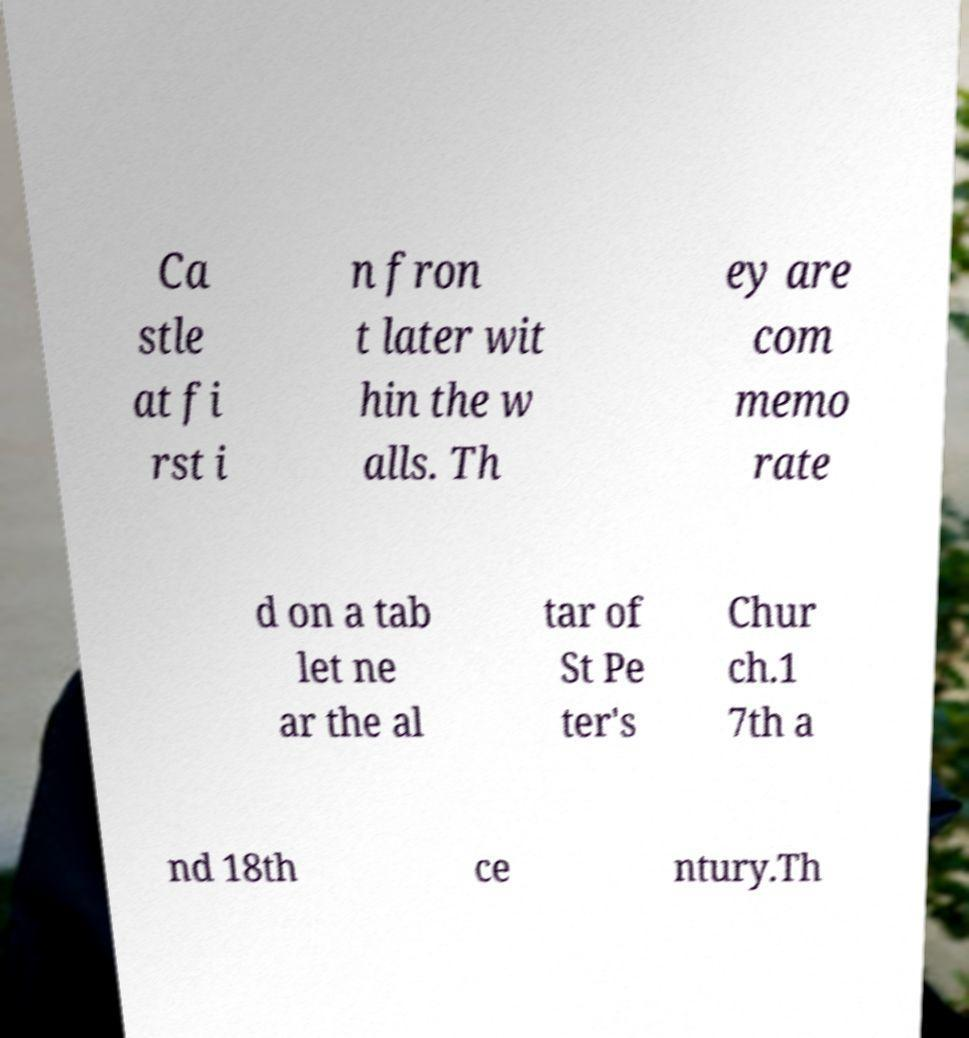There's text embedded in this image that I need extracted. Can you transcribe it verbatim? Ca stle at fi rst i n fron t later wit hin the w alls. Th ey are com memo rate d on a tab let ne ar the al tar of St Pe ter's Chur ch.1 7th a nd 18th ce ntury.Th 